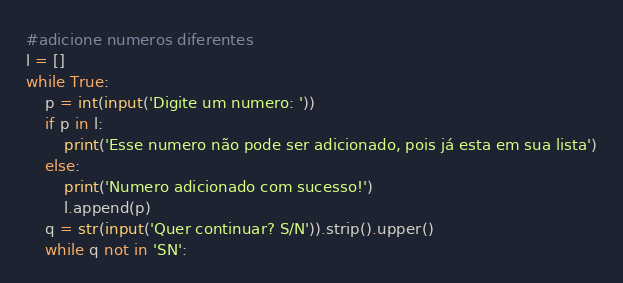Convert code to text. <code><loc_0><loc_0><loc_500><loc_500><_Python_>#adicione numeros diferentes
l = []
while True:
    p = int(input('Digite um numero: '))
    if p in l:
        print('Esse numero não pode ser adicionado, pois já esta em sua lista')
    else:
        print('Numero adicionado com sucesso!')
        l.append(p)
    q = str(input('Quer continuar? S/N')).strip().upper()
    while q not in 'SN':</code> 